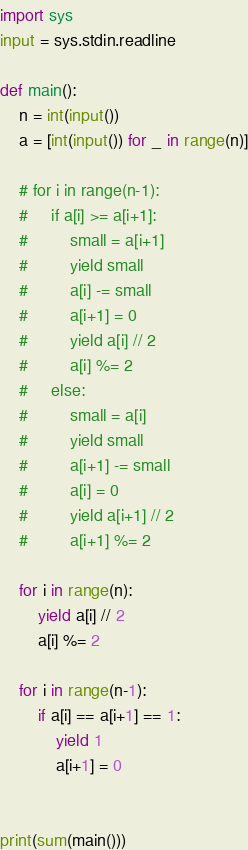Convert code to text. <code><loc_0><loc_0><loc_500><loc_500><_Python_>import sys
input = sys.stdin.readline

def main():
    n = int(input())
    a = [int(input()) for _ in range(n)]

    # for i in range(n-1):
    #     if a[i] >= a[i+1]:
    #         small = a[i+1]
    #         yield small
    #         a[i] -= small
    #         a[i+1] = 0
    #         yield a[i] // 2
    #         a[i] %= 2
    #     else:
    #         small = a[i]
    #         yield small
    #         a[i+1] -= small
    #         a[i] = 0
    #         yield a[i+1] // 2
    #         a[i+1] %= 2

    for i in range(n):
        yield a[i] // 2
        a[i] %= 2

    for i in range(n-1):
        if a[i] == a[i+1] == 1:
            yield 1
            a[i+1] = 0


print(sum(main()))</code> 